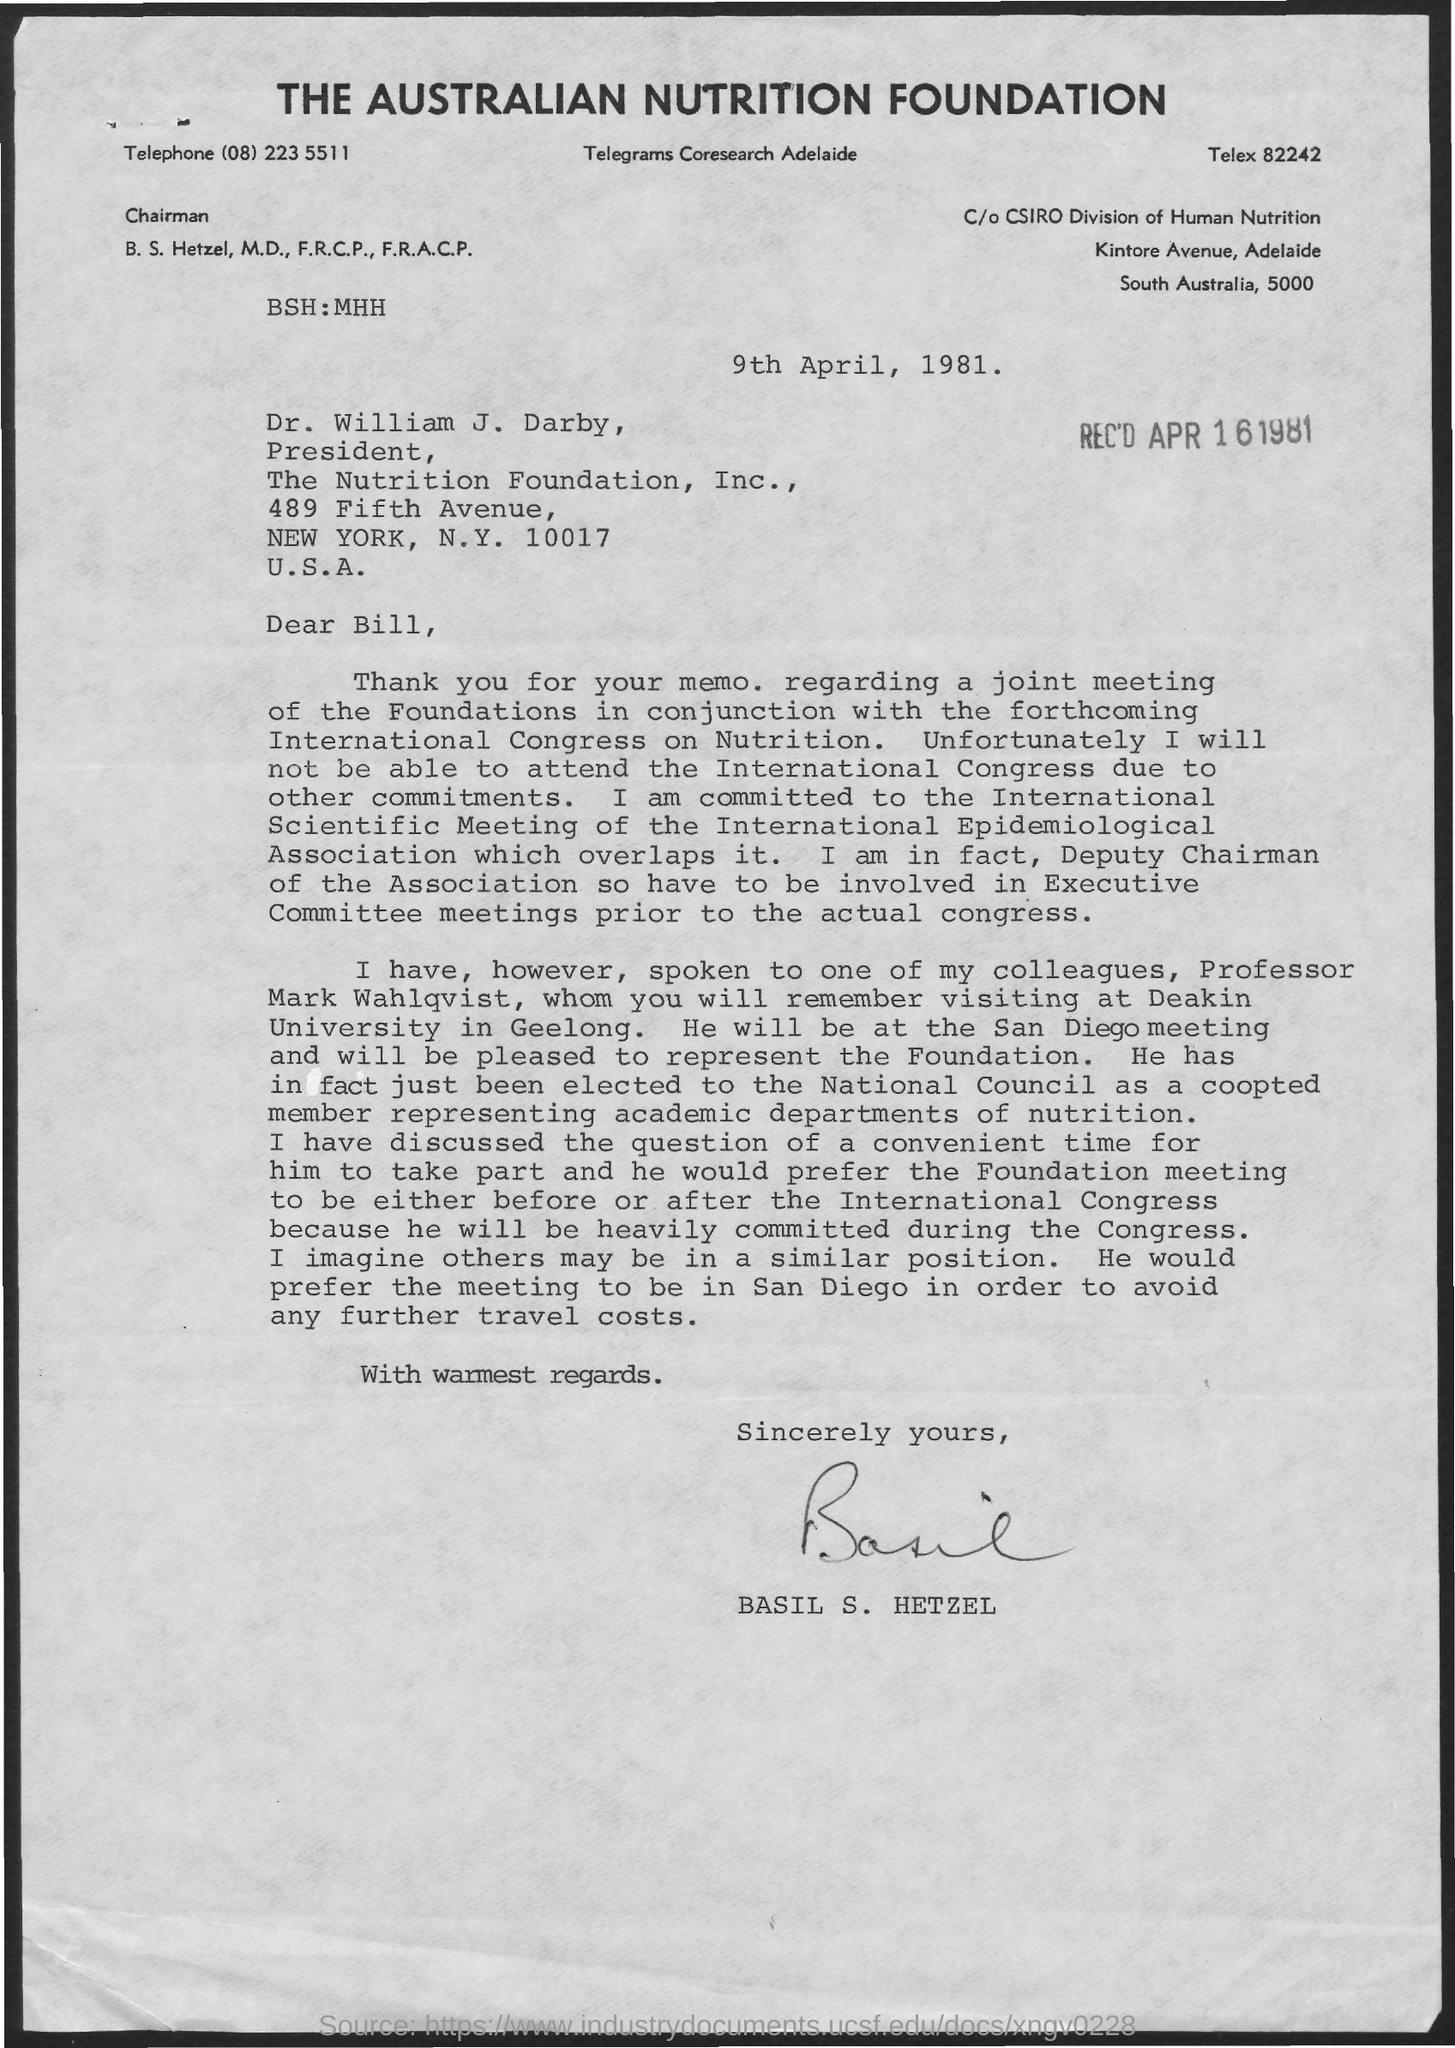Who is the sender of the memo.?
Provide a succinct answer. BASIL S. HETZEL. What is the issued date of this memo.?
Make the answer very short. 9th April, 1981. What is the Telephone no mentioned in the memo?
Ensure brevity in your answer.  (08) 223 5511. 